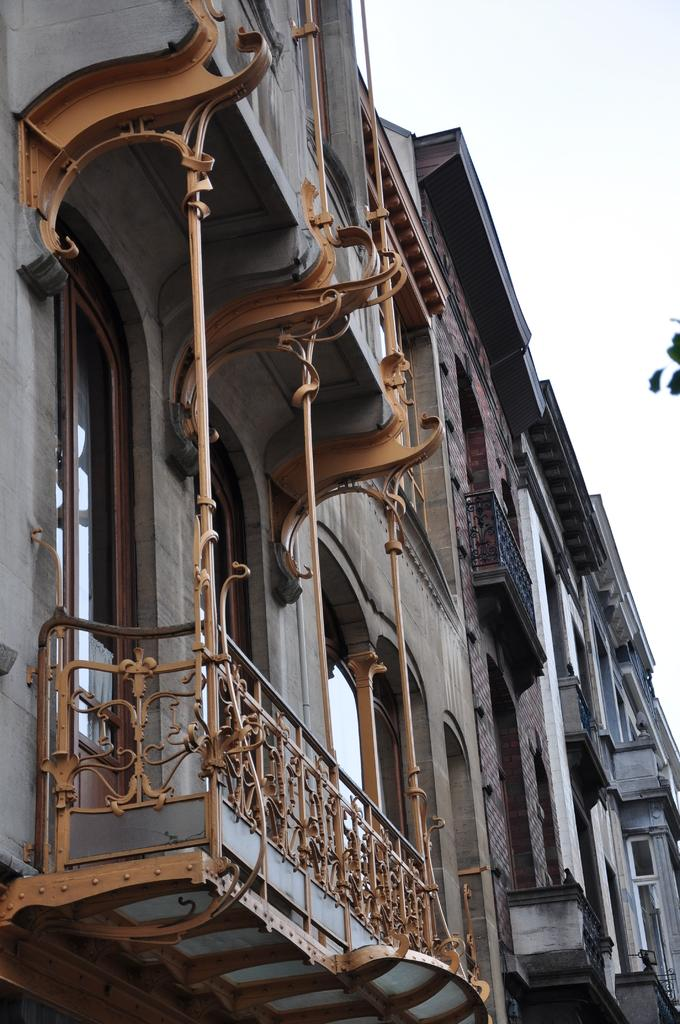How many buildings are present in the image? There are two buildings in the image. What feature is associated with the buildings? There is a balcony associated with the buildings. Can you see any shocks coming from the buildings in the image? There is no mention of shocks in the image, and therefore it cannot be determined if any are present. 